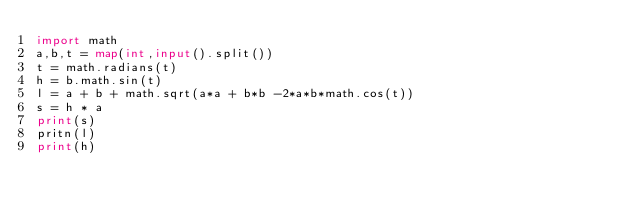Convert code to text. <code><loc_0><loc_0><loc_500><loc_500><_Python_>import math
a,b,t = map(int,input().split())
t = math.radians(t)
h = b.math.sin(t)
l = a + b + math.sqrt(a*a + b*b -2*a*b*math.cos(t))
s = h * a
print(s)
pritn(l)
print(h)</code> 